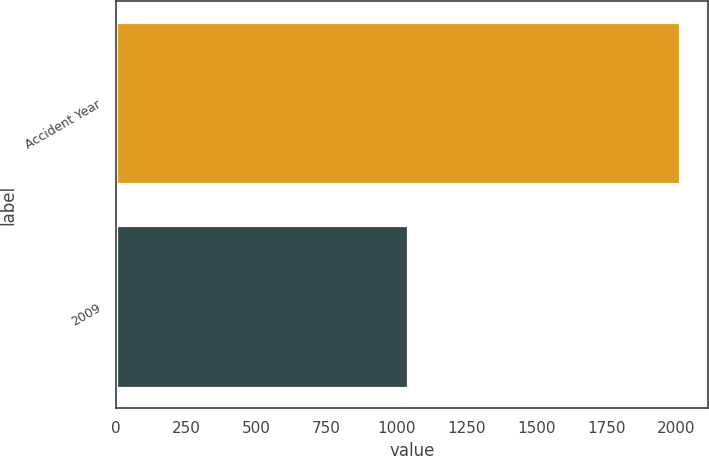Convert chart. <chart><loc_0><loc_0><loc_500><loc_500><bar_chart><fcel>Accident Year<fcel>2009<nl><fcel>2013<fcel>1042<nl></chart> 